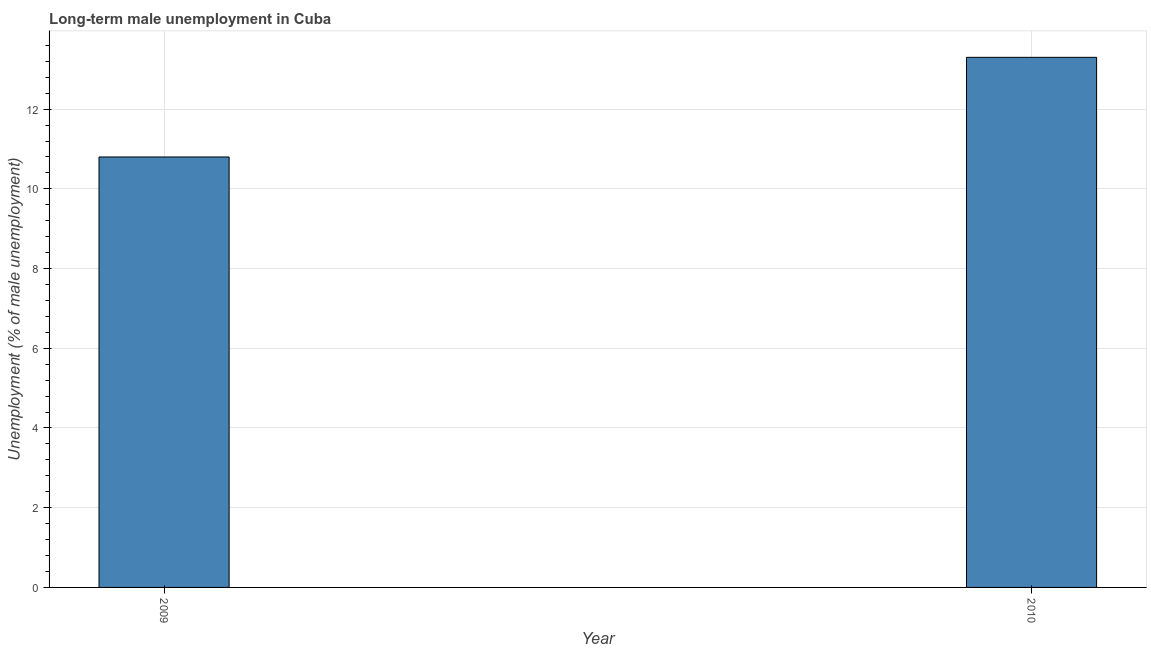Does the graph contain any zero values?
Make the answer very short. No. Does the graph contain grids?
Ensure brevity in your answer.  Yes. What is the title of the graph?
Your answer should be compact. Long-term male unemployment in Cuba. What is the label or title of the X-axis?
Offer a very short reply. Year. What is the label or title of the Y-axis?
Provide a short and direct response. Unemployment (% of male unemployment). What is the long-term male unemployment in 2010?
Offer a terse response. 13.3. Across all years, what is the maximum long-term male unemployment?
Keep it short and to the point. 13.3. Across all years, what is the minimum long-term male unemployment?
Make the answer very short. 10.8. In which year was the long-term male unemployment maximum?
Your answer should be compact. 2010. What is the sum of the long-term male unemployment?
Your answer should be compact. 24.1. What is the difference between the long-term male unemployment in 2009 and 2010?
Your response must be concise. -2.5. What is the average long-term male unemployment per year?
Your response must be concise. 12.05. What is the median long-term male unemployment?
Ensure brevity in your answer.  12.05. Do a majority of the years between 2009 and 2010 (inclusive) have long-term male unemployment greater than 7.6 %?
Keep it short and to the point. Yes. What is the ratio of the long-term male unemployment in 2009 to that in 2010?
Make the answer very short. 0.81. Is the long-term male unemployment in 2009 less than that in 2010?
Your answer should be very brief. Yes. How many bars are there?
Your response must be concise. 2. What is the difference between two consecutive major ticks on the Y-axis?
Your answer should be very brief. 2. What is the Unemployment (% of male unemployment) of 2009?
Provide a short and direct response. 10.8. What is the Unemployment (% of male unemployment) of 2010?
Your answer should be very brief. 13.3. What is the difference between the Unemployment (% of male unemployment) in 2009 and 2010?
Your answer should be compact. -2.5. What is the ratio of the Unemployment (% of male unemployment) in 2009 to that in 2010?
Your answer should be compact. 0.81. 